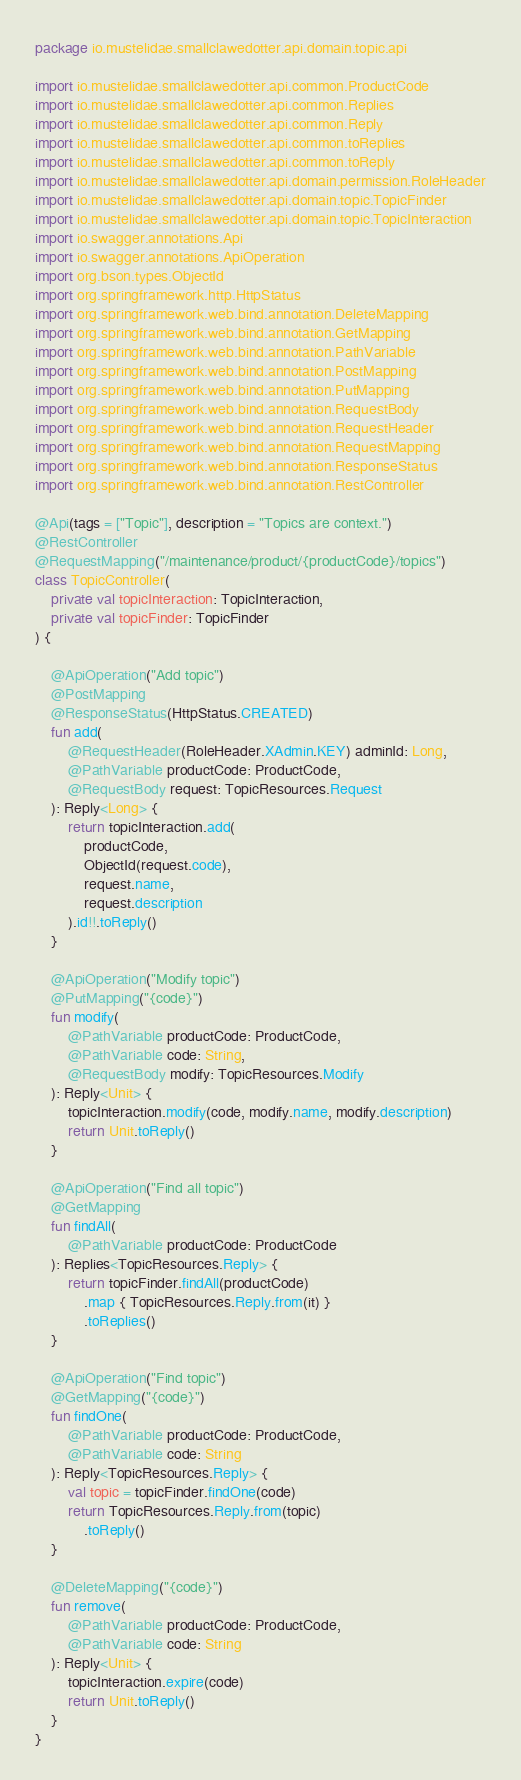<code> <loc_0><loc_0><loc_500><loc_500><_Kotlin_>package io.mustelidae.smallclawedotter.api.domain.topic.api

import io.mustelidae.smallclawedotter.api.common.ProductCode
import io.mustelidae.smallclawedotter.api.common.Replies
import io.mustelidae.smallclawedotter.api.common.Reply
import io.mustelidae.smallclawedotter.api.common.toReplies
import io.mustelidae.smallclawedotter.api.common.toReply
import io.mustelidae.smallclawedotter.api.domain.permission.RoleHeader
import io.mustelidae.smallclawedotter.api.domain.topic.TopicFinder
import io.mustelidae.smallclawedotter.api.domain.topic.TopicInteraction
import io.swagger.annotations.Api
import io.swagger.annotations.ApiOperation
import org.bson.types.ObjectId
import org.springframework.http.HttpStatus
import org.springframework.web.bind.annotation.DeleteMapping
import org.springframework.web.bind.annotation.GetMapping
import org.springframework.web.bind.annotation.PathVariable
import org.springframework.web.bind.annotation.PostMapping
import org.springframework.web.bind.annotation.PutMapping
import org.springframework.web.bind.annotation.RequestBody
import org.springframework.web.bind.annotation.RequestHeader
import org.springframework.web.bind.annotation.RequestMapping
import org.springframework.web.bind.annotation.ResponseStatus
import org.springframework.web.bind.annotation.RestController

@Api(tags = ["Topic"], description = "Topics are context.")
@RestController
@RequestMapping("/maintenance/product/{productCode}/topics")
class TopicController(
    private val topicInteraction: TopicInteraction,
    private val topicFinder: TopicFinder
) {

    @ApiOperation("Add topic")
    @PostMapping
    @ResponseStatus(HttpStatus.CREATED)
    fun add(
        @RequestHeader(RoleHeader.XAdmin.KEY) adminId: Long,
        @PathVariable productCode: ProductCode,
        @RequestBody request: TopicResources.Request
    ): Reply<Long> {
        return topicInteraction.add(
            productCode,
            ObjectId(request.code),
            request.name,
            request.description
        ).id!!.toReply()
    }

    @ApiOperation("Modify topic")
    @PutMapping("{code}")
    fun modify(
        @PathVariable productCode: ProductCode,
        @PathVariable code: String,
        @RequestBody modify: TopicResources.Modify
    ): Reply<Unit> {
        topicInteraction.modify(code, modify.name, modify.description)
        return Unit.toReply()
    }

    @ApiOperation("Find all topic")
    @GetMapping
    fun findAll(
        @PathVariable productCode: ProductCode
    ): Replies<TopicResources.Reply> {
        return topicFinder.findAll(productCode)
            .map { TopicResources.Reply.from(it) }
            .toReplies()
    }

    @ApiOperation("Find topic")
    @GetMapping("{code}")
    fun findOne(
        @PathVariable productCode: ProductCode,
        @PathVariable code: String
    ): Reply<TopicResources.Reply> {
        val topic = topicFinder.findOne(code)
        return TopicResources.Reply.from(topic)
            .toReply()
    }

    @DeleteMapping("{code}")
    fun remove(
        @PathVariable productCode: ProductCode,
        @PathVariable code: String
    ): Reply<Unit> {
        topicInteraction.expire(code)
        return Unit.toReply()
    }
}
</code> 